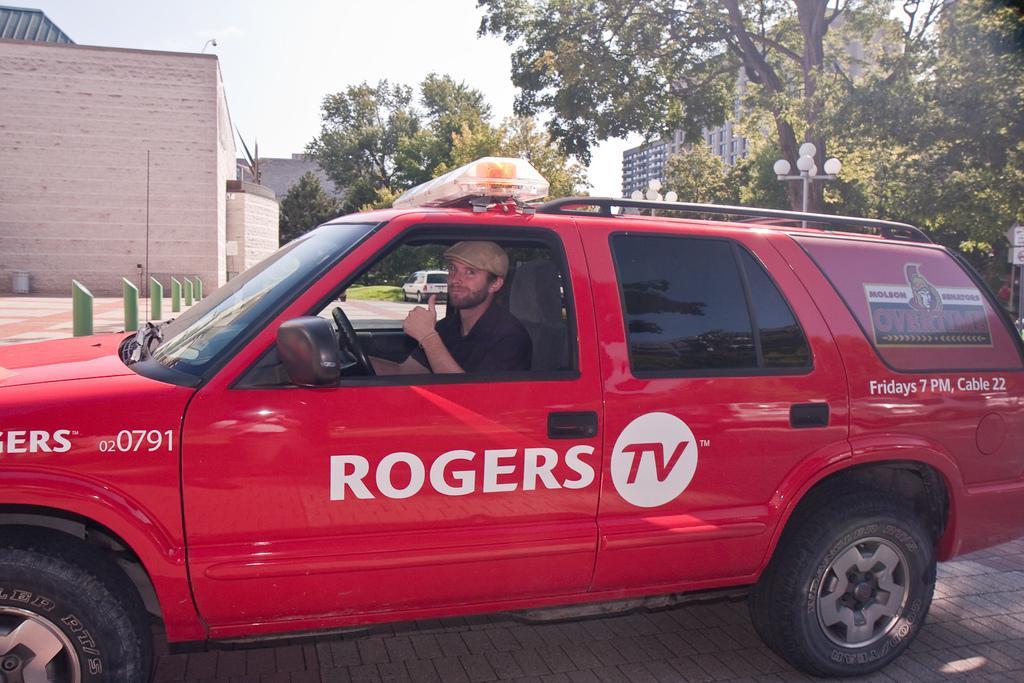Please provide a concise description of this image. At the top we can see sky. We can see buildings and house. these are trees. These are lights. Here we can see one man inside a car and showing his thumb finger. He wore a cap. 